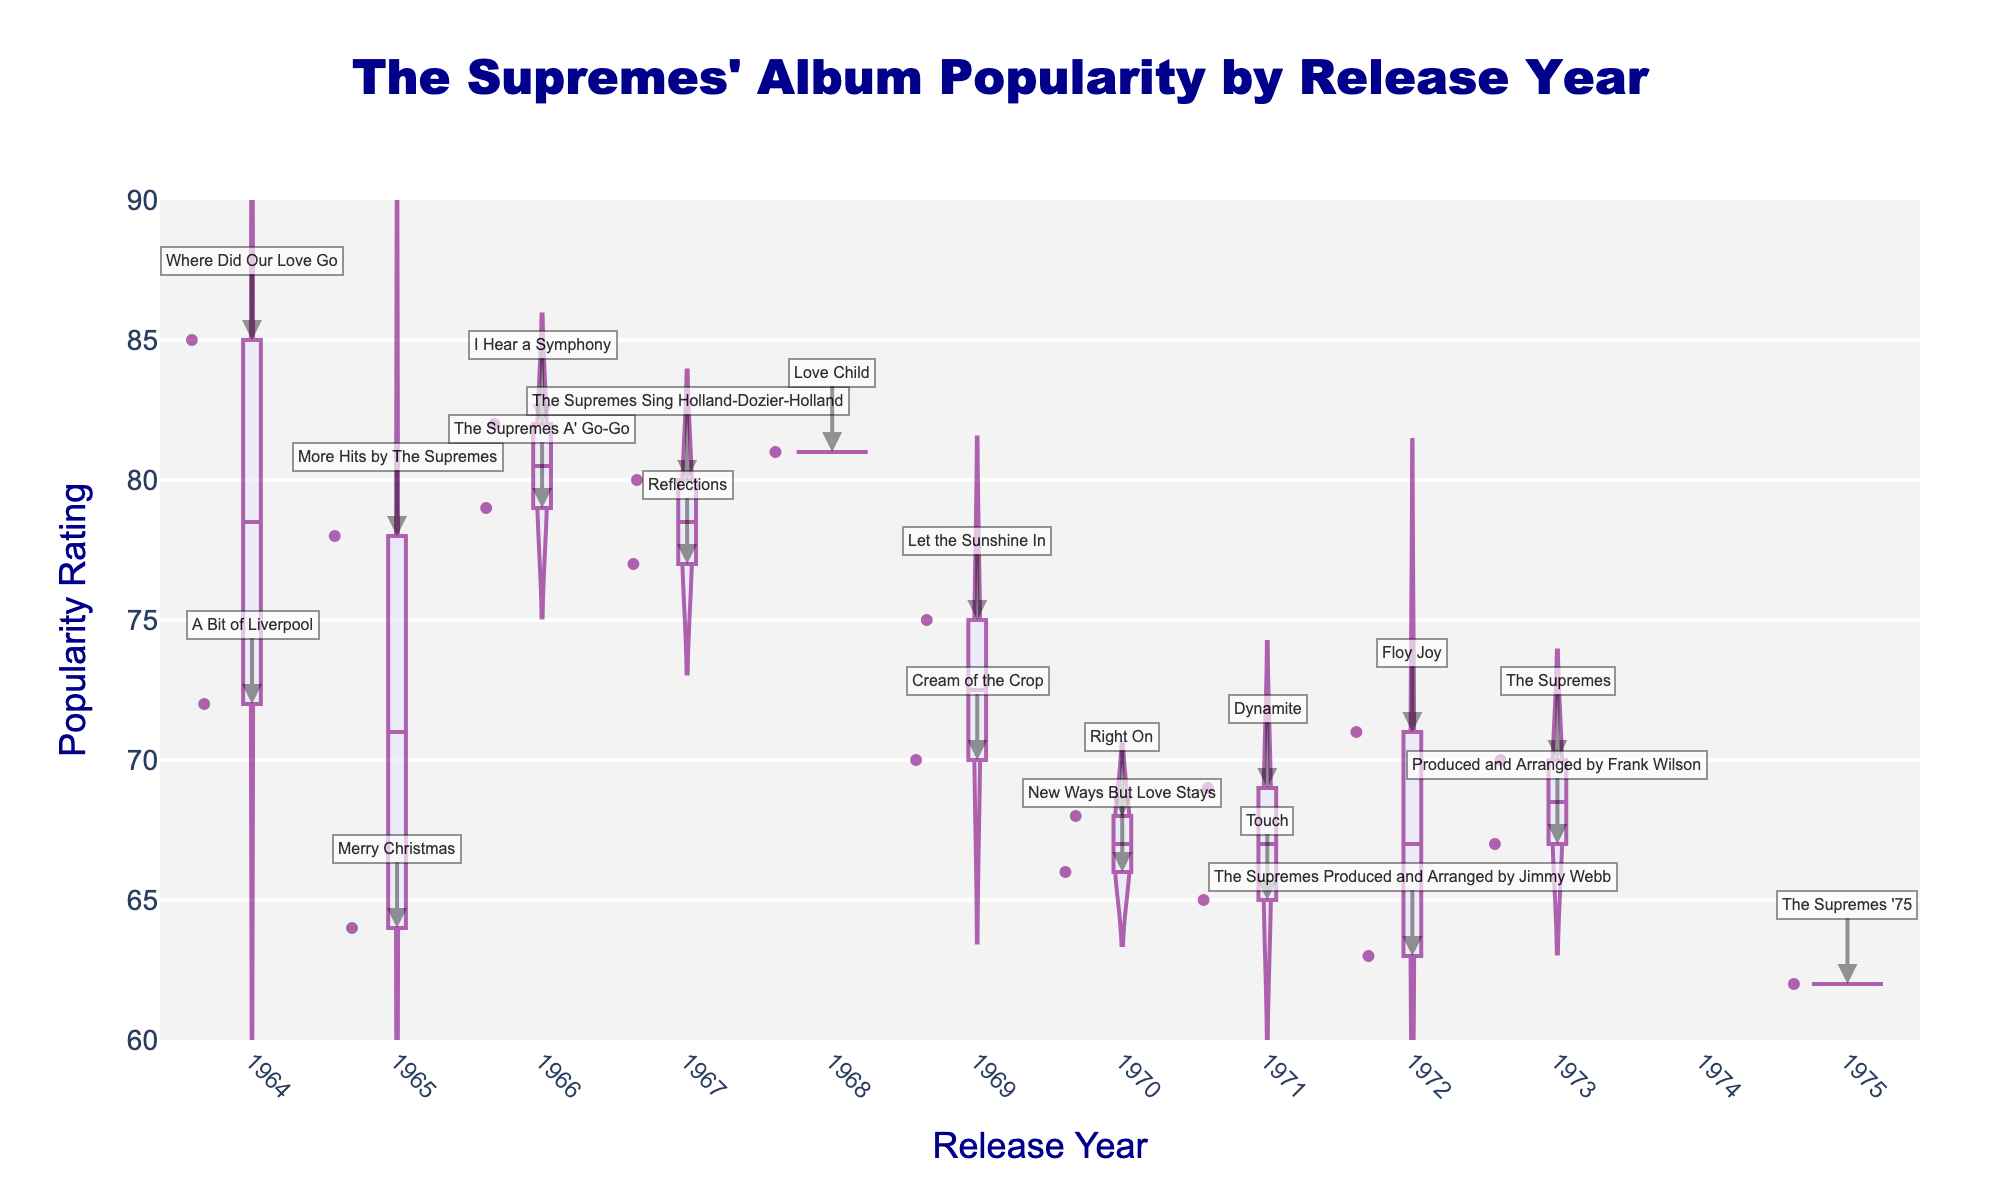what is the title of the plot? The title of the plot is displayed at the top center in a larger, dark blue font. It provides a brief description of the plotted data.
Answer: The Supremes' Album Popularity by Release Year What are the y-axis range and tick increments? The y-axis represents popularity ratings and ranges from 60 to 90 with tick increments of 5.
Answer: 60 to 90, increments of 5 Identify the album released in 1965 with the lowest popularity rating The plot shows annotations of album names. "Merry Christmas" released in 1965 has the lowest popularity rating.
Answer: Merry Christmas Which year had the most album releases? By counting the number of violin plot points and checking annotations, 1971 had two albums, which is more compared to other years.
Answer: 1971 Compare the popularity rating of "Where Did Our Love Go" (1964) to "Let the Sunshine In" (1969). Which is higher? By checking the annotations and y-axis positions, "Where Did Our Love Go" (85) is higher than "Let the Sunshine In" (75).
Answer: Where Did Our Love Go How many albums were released between 1968 and 1972? Count the number of data points and annotations within the range 1968 to 1972. There are six albums.
Answer: 6 Which album had the highest popularity rating? Check the violin plot's y-axis values and annotations. "Where Did Our Love Go" in 1964 had the highest rating of 85.
Answer: Where Did Our Love Go What's the average popularity rating of albums released in 1970? Add the popularity ratings for 1970's albums (68 and 66) and divide by the number of albums: (68 + 66) / 2 = 67.
Answer: 67 Which album released after 1970 has the lowest popularity rating? Check the annotations and y-axis ratings for albums released after 1970. "The Supremes '75" (1975) has the lowest rating of 62.
Answer: The Supremes '75 Is the median popularity rating for albums released between 1971 and 1973 greater than that of albums released before 1968? Compare sorted ratings: 1971-1973: 65, 67, 69, 70 (median 68) vs. pre-1968: 64, 72, 75, 77, 78, 79, 80, 82, 85 (median 78). Median for later years is not greater than the median for earlier years.
Answer: No 